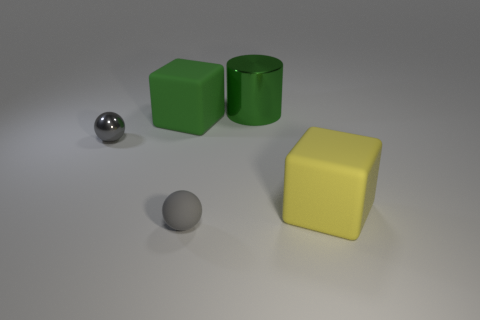Add 5 shiny spheres. How many objects exist? 10 Subtract all cubes. How many objects are left? 3 Add 3 green rubber cubes. How many green rubber cubes are left? 4 Add 5 tiny metallic spheres. How many tiny metallic spheres exist? 6 Subtract 0 gray cylinders. How many objects are left? 5 Subtract all small red rubber blocks. Subtract all green blocks. How many objects are left? 4 